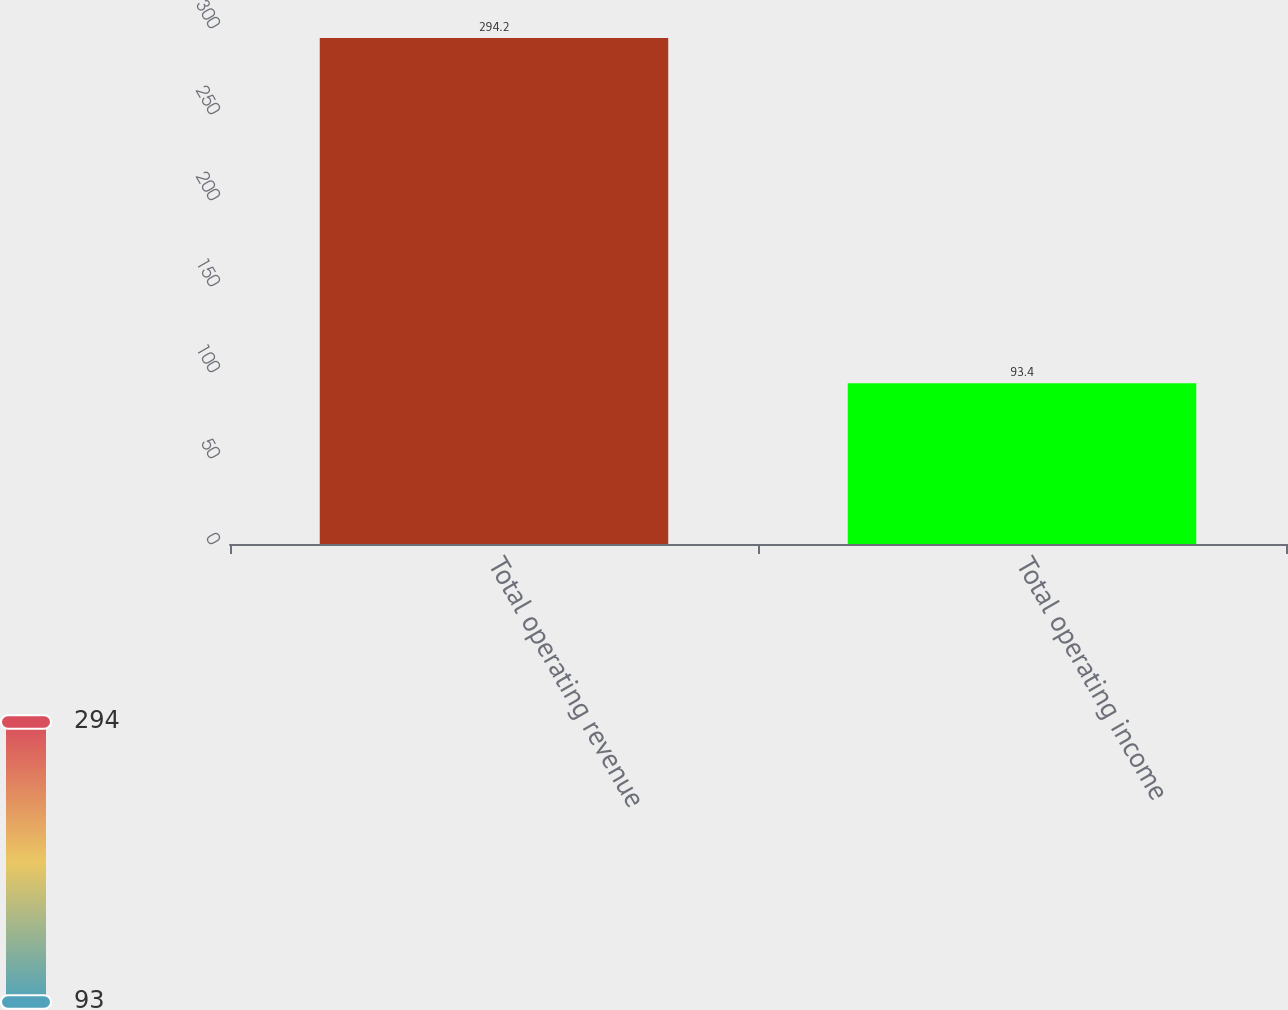Convert chart. <chart><loc_0><loc_0><loc_500><loc_500><bar_chart><fcel>Total operating revenue<fcel>Total operating income<nl><fcel>294.2<fcel>93.4<nl></chart> 